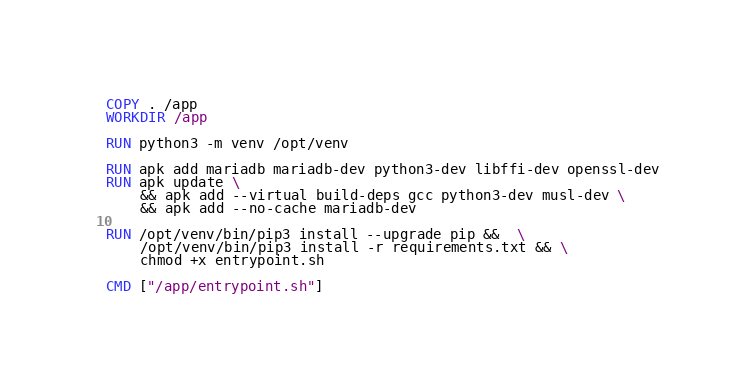<code> <loc_0><loc_0><loc_500><loc_500><_Dockerfile_>
COPY . /app
WORKDIR /app

RUN python3 -m venv /opt/venv

RUN apk add mariadb mariadb-dev python3-dev libffi-dev openssl-dev
RUN apk update \
    && apk add --virtual build-deps gcc python3-dev musl-dev \
    && apk add --no-cache mariadb-dev

RUN /opt/venv/bin/pip3 install --upgrade pip &&  \
    /opt/venv/bin/pip3 install -r requirements.txt && \
    chmod +x entrypoint.sh

CMD ["/app/entrypoint.sh"]</code> 